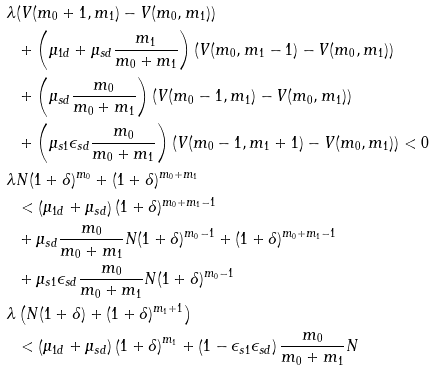Convert formula to latex. <formula><loc_0><loc_0><loc_500><loc_500>\lambda & ( V ( m _ { 0 } + 1 , m _ { 1 } ) - V ( m _ { 0 } , m _ { 1 } ) ) \\ & + \left ( \mu _ { 1 d } + \mu _ { s d } \frac { m _ { 1 } } { m _ { 0 } + m _ { 1 } } \right ) ( V ( m _ { 0 } , m _ { 1 } - 1 ) - V ( m _ { 0 } , m _ { 1 } ) ) \\ & + \left ( \mu _ { s d } \frac { m _ { 0 } } { m _ { 0 } + m _ { 1 } } \right ) ( V ( m _ { 0 } - 1 , m _ { 1 } ) - V ( m _ { 0 } , m _ { 1 } ) ) \\ & + \left ( \mu _ { s 1 } \epsilon _ { s d } \frac { m _ { 0 } } { m _ { 0 } + m _ { 1 } } \right ) ( V ( m _ { 0 } - 1 , m _ { 1 } + 1 ) - V ( m _ { 0 } , m _ { 1 } ) ) < 0 \\ \lambda & N ( 1 + \delta ) ^ { m _ { 0 } } + ( 1 + \delta ) ^ { m _ { 0 } + m _ { 1 } } \\ & < \left ( \mu _ { 1 d } + \mu _ { s d } \right ) ( 1 + \delta ) ^ { m _ { 0 } + m _ { 1 } - 1 } \\ & + \mu _ { s d } \frac { m _ { 0 } } { m _ { 0 } + m _ { 1 } } N ( 1 + \delta ) ^ { m _ { 0 } - 1 } + ( 1 + \delta ) ^ { m _ { 0 } + m _ { 1 } - 1 } \\ & + \mu _ { s 1 } \epsilon _ { s d } \frac { m _ { 0 } } { m _ { 0 } + m _ { 1 } } N ( 1 + \delta ) ^ { m _ { 0 } - 1 } \\ \lambda & \left ( N ( 1 + \delta ) + ( 1 + \delta ) ^ { m _ { 1 } + 1 } \right ) \\ & < \left ( \mu _ { 1 d } + \mu _ { s d } \right ) \left ( 1 + \delta \right ) ^ { m _ { 1 } } + \left ( 1 - \epsilon _ { s 1 } \epsilon _ { s d } \right ) \frac { m _ { 0 } } { m _ { 0 } + m _ { 1 } } N</formula> 